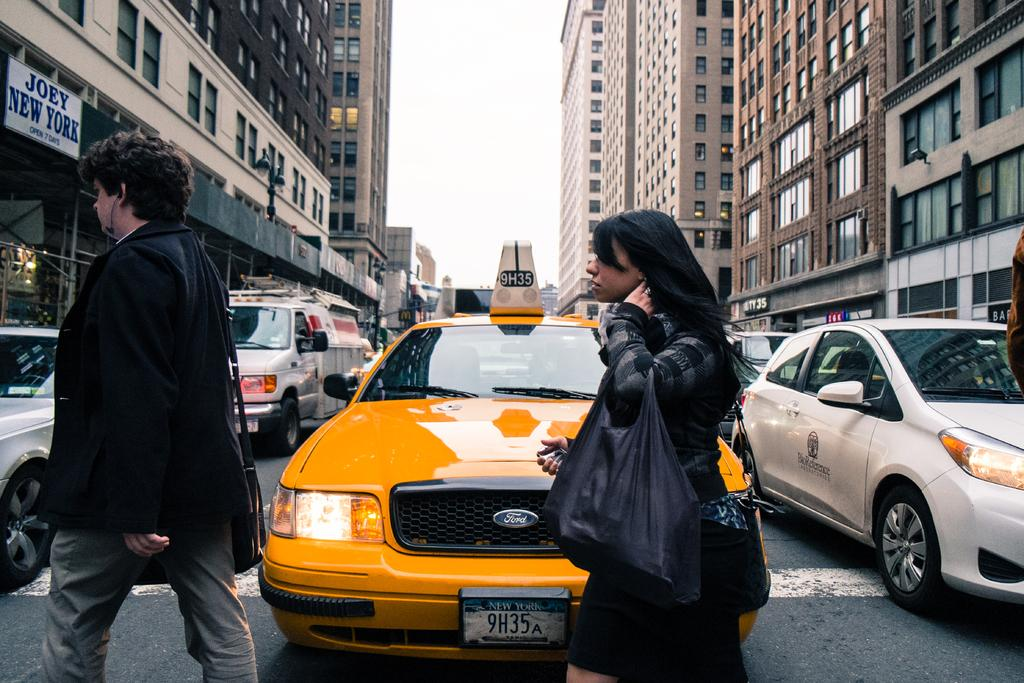Provide a one-sentence caption for the provided image. A taxi cab has a New York license plate number of 9H35A. 